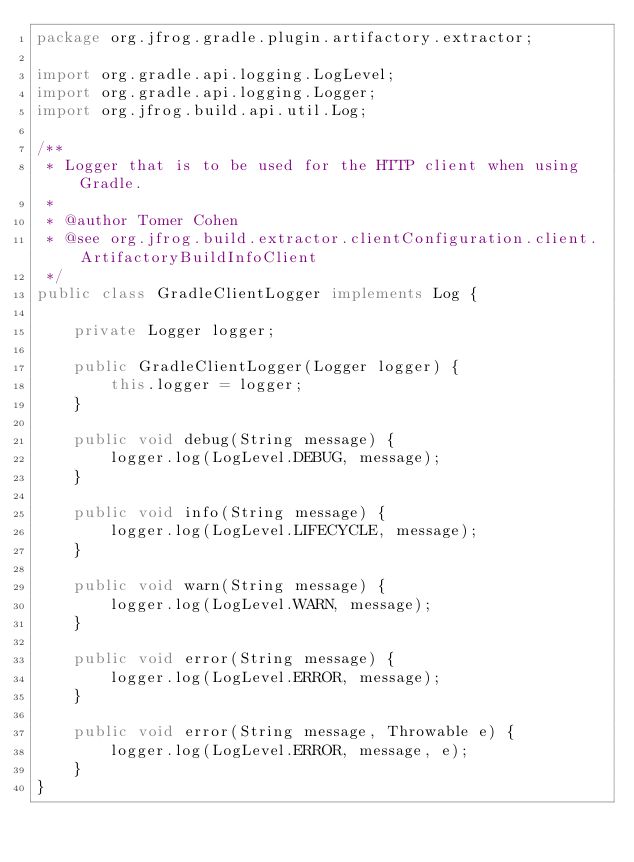Convert code to text. <code><loc_0><loc_0><loc_500><loc_500><_Java_>package org.jfrog.gradle.plugin.artifactory.extractor;

import org.gradle.api.logging.LogLevel;
import org.gradle.api.logging.Logger;
import org.jfrog.build.api.util.Log;

/**
 * Logger that is to be used for the HTTP client when using Gradle.
 *
 * @author Tomer Cohen
 * @see org.jfrog.build.extractor.clientConfiguration.client.ArtifactoryBuildInfoClient
 */
public class GradleClientLogger implements Log {

    private Logger logger;

    public GradleClientLogger(Logger logger) {
        this.logger = logger;
    }

    public void debug(String message) {
        logger.log(LogLevel.DEBUG, message);
    }

    public void info(String message) {
        logger.log(LogLevel.LIFECYCLE, message);
    }

    public void warn(String message) {
        logger.log(LogLevel.WARN, message);
    }

    public void error(String message) {
        logger.log(LogLevel.ERROR, message);
    }

    public void error(String message, Throwable e) {
        logger.log(LogLevel.ERROR, message, e);
    }
}
</code> 